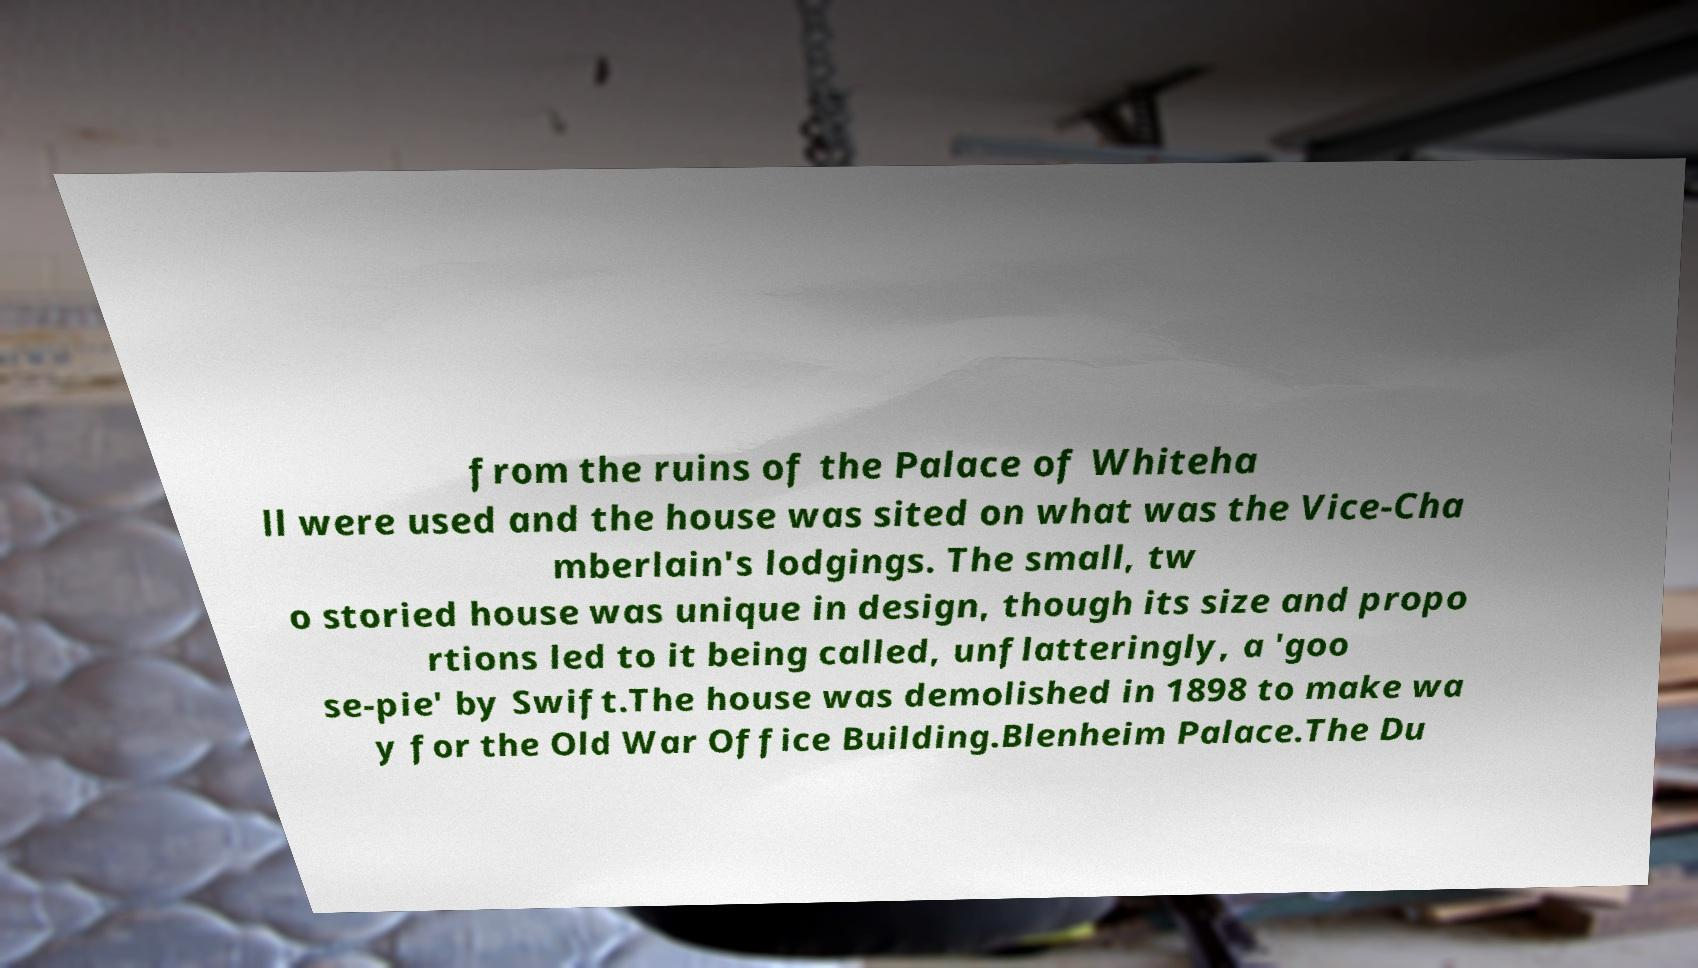Please read and relay the text visible in this image. What does it say? from the ruins of the Palace of Whiteha ll were used and the house was sited on what was the Vice-Cha mberlain's lodgings. The small, tw o storied house was unique in design, though its size and propo rtions led to it being called, unflatteringly, a 'goo se-pie' by Swift.The house was demolished in 1898 to make wa y for the Old War Office Building.Blenheim Palace.The Du 